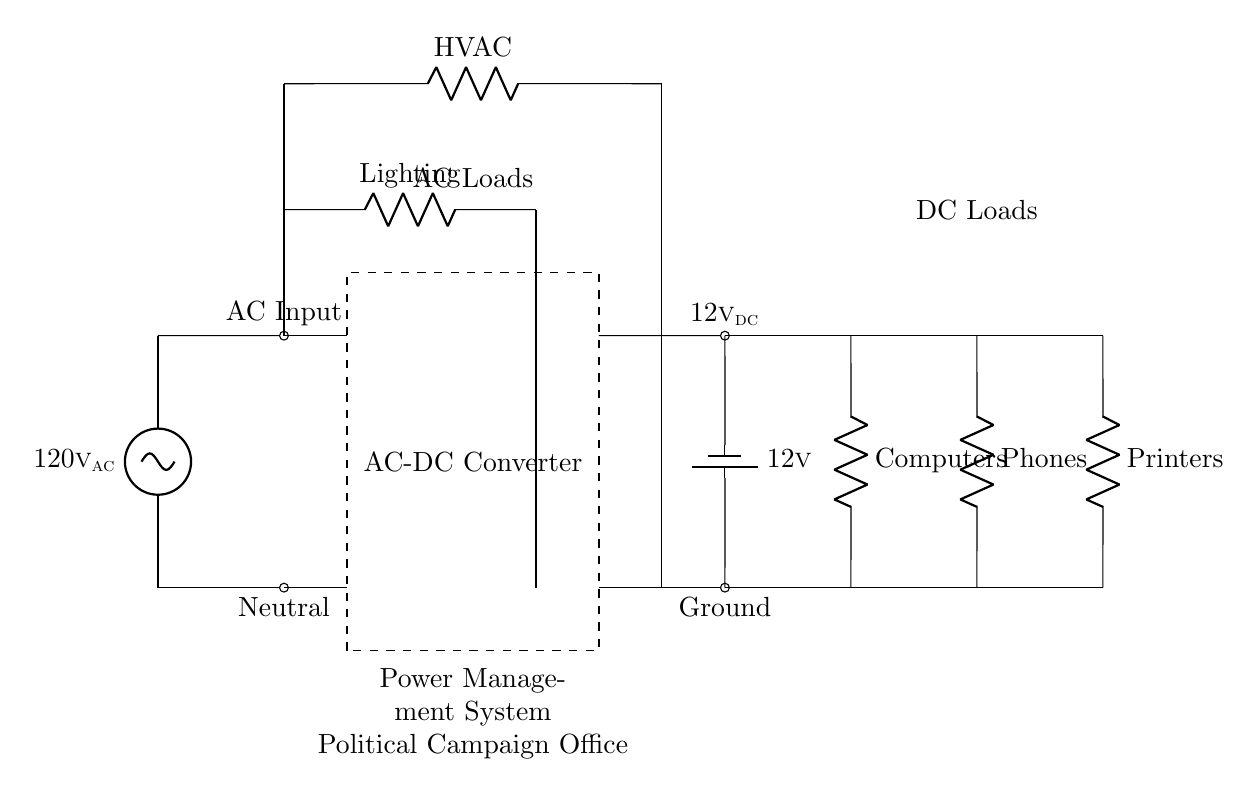What is the voltage of the AC power source? The voltage of the AC power source is labeled as 120 volts AC. This can be found directly on the diagram near the AC voltage source symbol.
Answer: 120 volts AC What type of conversion does the dashed rectangle represent? The dashed rectangle represents an AC to DC conversion. This can be inferred from its position in the circuit between the AC power source and the DC output, indicating its function as a converter for voltage types.
Answer: AC to DC conversion How many DC loads are shown in the diagram? The diagram shows three DC loads, which are labeled as Computers, Phones, and Printers. They are connected to the DC output of the AC-DC converter, visible by the distinct lines coming from the DC voltage source.
Answer: Three What is the purpose of the battery in the circuit? The battery's purpose is to provide a stable 12 volts DC, which serves as a backup power source for the DC loads. It is directly connected to the DC output, ensuring that these components receive power even when the AC power is not available.
Answer: Backup power source What is the total number of AC loads depicted? There are two AC loads, identified as Lighting and HVAC. The diagram clearly shows these components connected to the AC power source, indicating their operational status in the circuit.
Answer: Two 